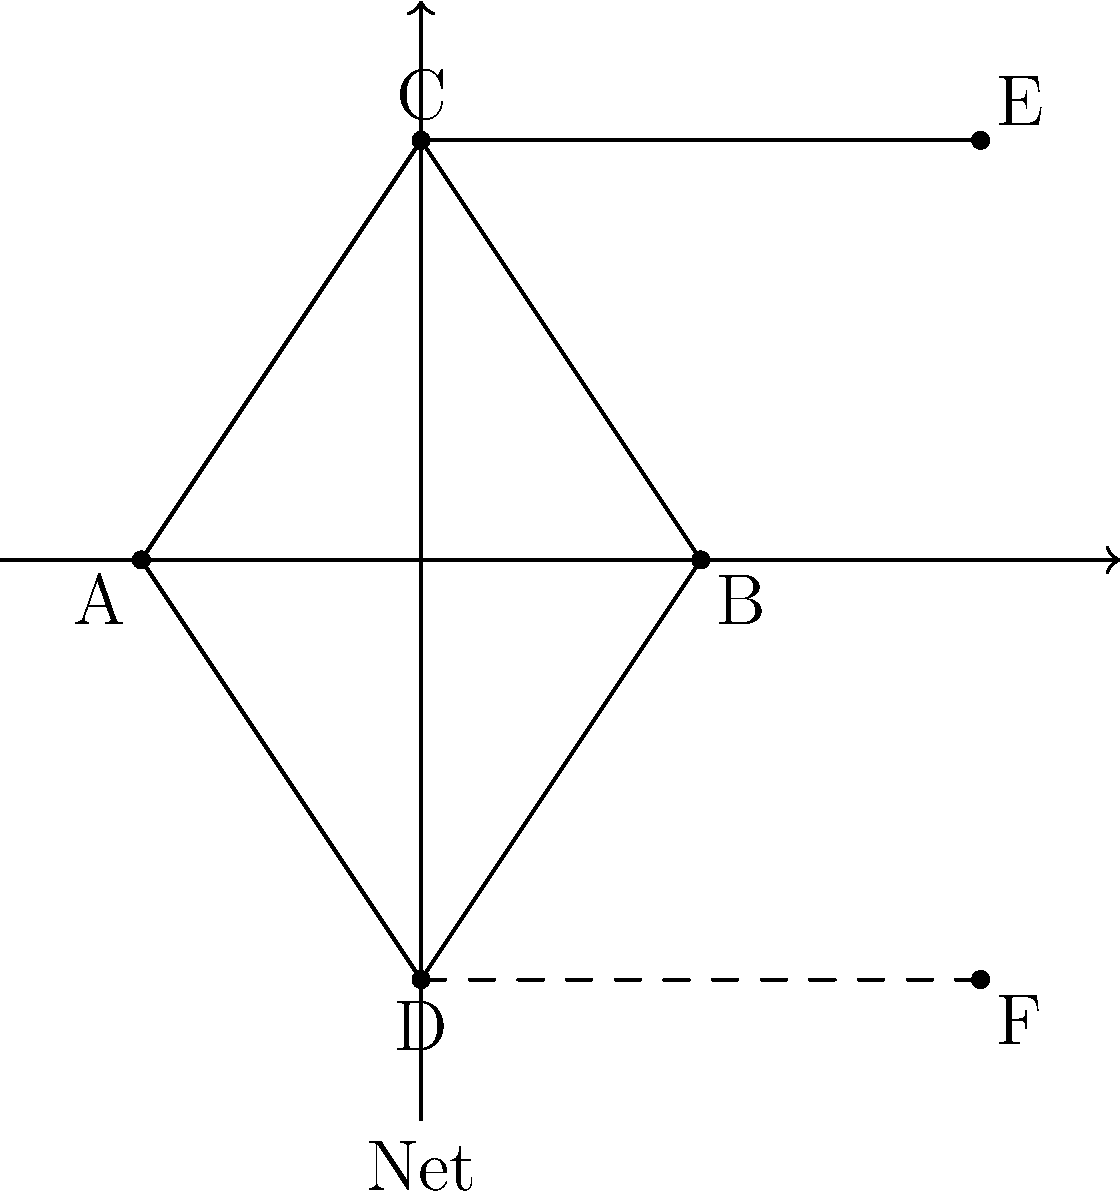In a doubles badminton match in Rio de Janeiro, players are positioned as shown in the diagram. Points A, B, C, and D represent the four players on one side of the court. If the formation undergoes a reflection across the net (represented by the y-axis), what are the coordinates of point F, which is the reflection of point C? To solve this problem, we need to apply the concept of reflection symmetry across the y-axis. Here's a step-by-step explanation:

1. Identify the coordinates of point C: From the diagram, we can see that C is at (2,3).

2. Recall the rule for reflection across the y-axis: When a point (x,y) is reflected across the y-axis, its new coordinates become (-x,y).

3. Apply the reflection rule to point C:
   - The x-coordinate changes sign: 2 becomes -2
   - The y-coordinate remains the same: 3 stays as 3

4. Therefore, the reflection of point C across the y-axis would be at (-2,3).

5. However, the question asks for the coordinates of point F, which is already drawn on the diagram.

6. Observe that F is not at (-2,3), but rather at (6,-3).

7. This means that after the reflection across the y-axis, there was an additional transformation applied:
   - A translation of 4 units to the right (from -2 to 6 on the x-axis)
   - A reflection across the x-axis (changing 3 to -3 on the y-axis)

8. These additional transformations maintain the symmetry of the formation on both sides of the net, which is a common practice in doubles badminton.
Answer: (6,-3) 